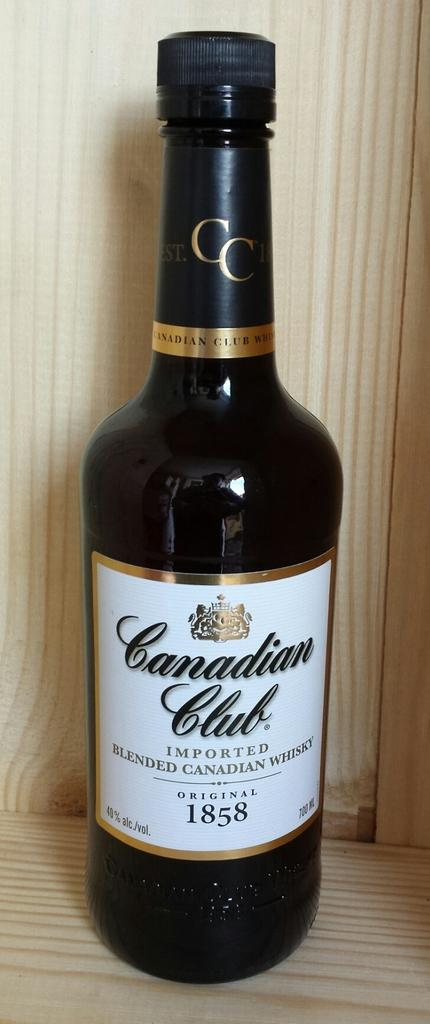Provide a one-sentence caption for the provided image. A dark bottle of whiskey by Canadian Club. 